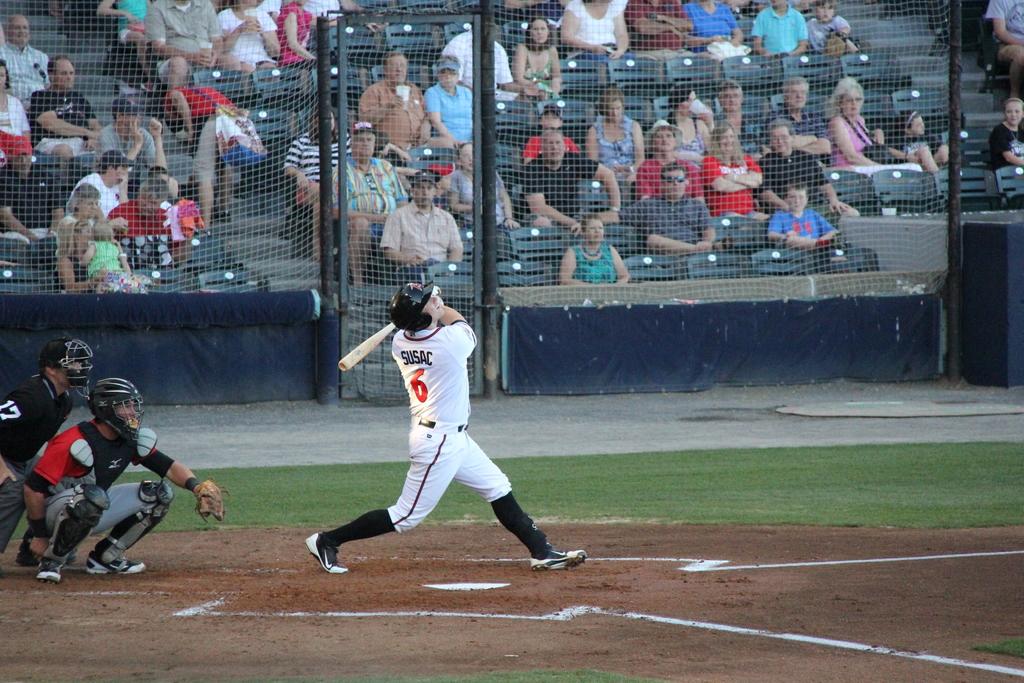What´s the number on the black shirt payer?
Ensure brevity in your answer.  6. 